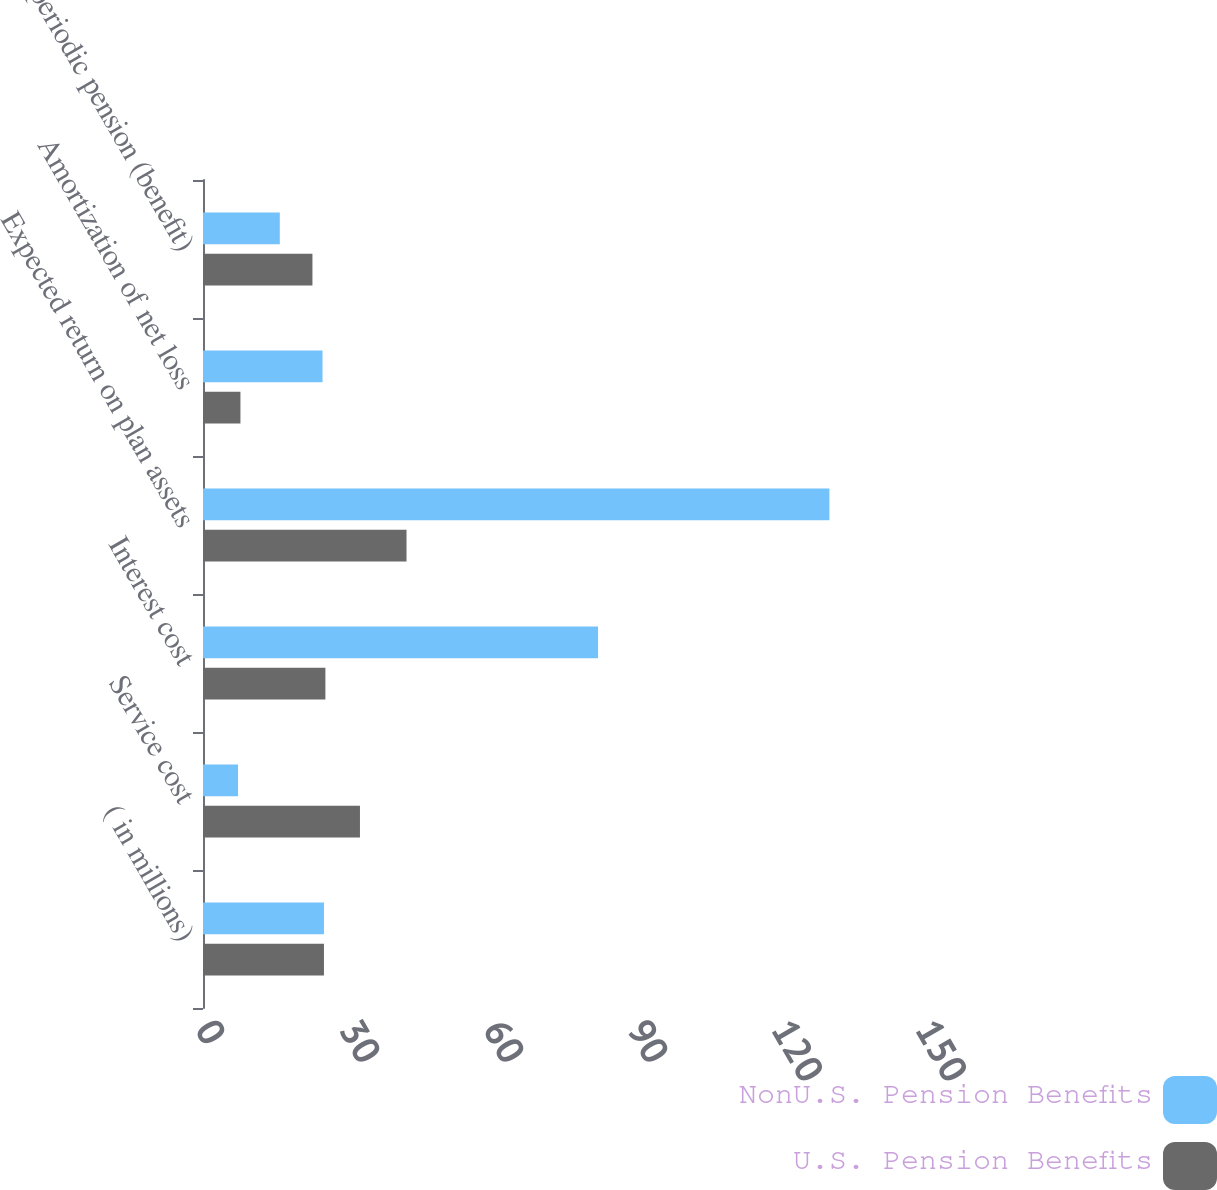Convert chart to OTSL. <chart><loc_0><loc_0><loc_500><loc_500><stacked_bar_chart><ecel><fcel>( in millions)<fcel>Service cost<fcel>Interest cost<fcel>Expected return on plan assets<fcel>Amortization of net loss<fcel>Net periodic pension (benefit)<nl><fcel>NonU.S. Pension Benefits<fcel>25.2<fcel>7.3<fcel>82.3<fcel>130.5<fcel>24.9<fcel>16<nl><fcel>U.S. Pension Benefits<fcel>25.2<fcel>32.7<fcel>25.5<fcel>42.4<fcel>7.8<fcel>22.8<nl></chart> 